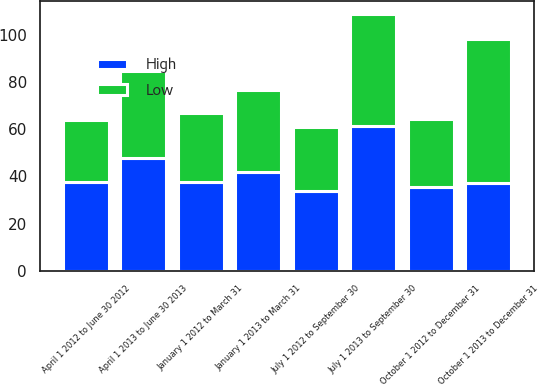Convert chart to OTSL. <chart><loc_0><loc_0><loc_500><loc_500><stacked_bar_chart><ecel><fcel>January 1 2013 to March 31<fcel>April 1 2013 to June 30 2013<fcel>July 1 2013 to September 30<fcel>October 1 2013 to December 31<fcel>January 1 2012 to March 31<fcel>April 1 2012 to June 30 2012<fcel>July 1 2012 to September 30<fcel>October 1 2012 to December 31<nl><fcel>High<fcel>41.85<fcel>47.8<fcel>61.47<fcel>37.09<fcel>37.79<fcel>37.65<fcel>34<fcel>35.3<nl><fcel>Low<fcel>34.79<fcel>37.09<fcel>47.59<fcel>61.34<fcel>29.26<fcel>26.22<fcel>26.88<fcel>29<nl></chart> 